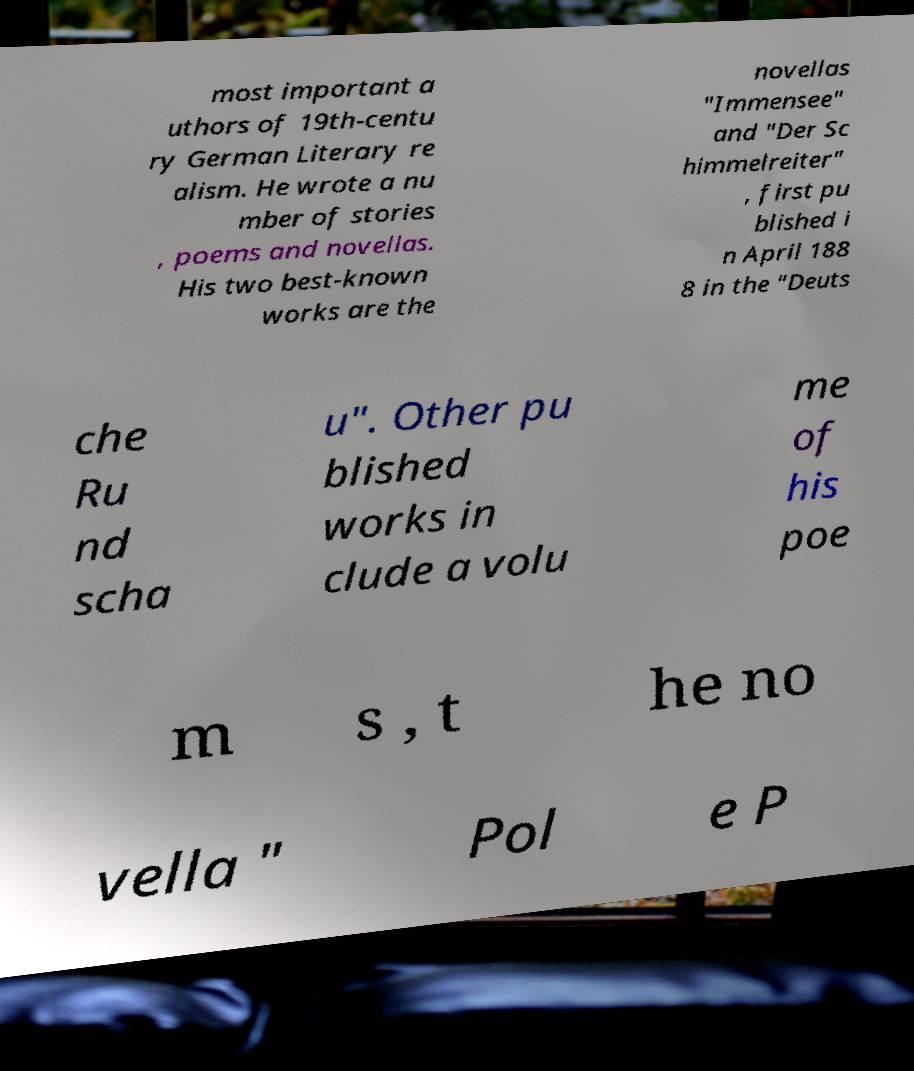Can you accurately transcribe the text from the provided image for me? most important a uthors of 19th-centu ry German Literary re alism. He wrote a nu mber of stories , poems and novellas. His two best-known works are the novellas "Immensee" and "Der Sc himmelreiter" , first pu blished i n April 188 8 in the "Deuts che Ru nd scha u". Other pu blished works in clude a volu me of his poe m s , t he no vella " Pol e P 